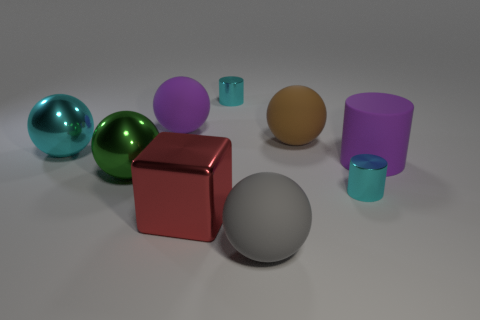How many other things are there of the same color as the big rubber cylinder?
Ensure brevity in your answer.  1. What number of matte cylinders are there?
Ensure brevity in your answer.  1. What number of large spheres are in front of the purple matte ball and on the right side of the green metal object?
Your response must be concise. 2. What is the brown thing made of?
Offer a terse response. Rubber. Are any small brown metallic spheres visible?
Your answer should be very brief. No. There is a big ball to the left of the large green metallic sphere; what is its color?
Your answer should be very brief. Cyan. There is a rubber thing that is left of the cylinder behind the big cyan sphere; how many big brown balls are on the left side of it?
Ensure brevity in your answer.  0. What is the material of the ball that is on the left side of the large brown rubber sphere and behind the large cyan shiny sphere?
Offer a very short reply. Rubber. Is the big brown ball made of the same material as the small cyan object behind the large green metallic object?
Offer a very short reply. No. Is the number of brown balls left of the brown matte ball greater than the number of purple matte objects that are to the left of the large gray thing?
Your response must be concise. No. 